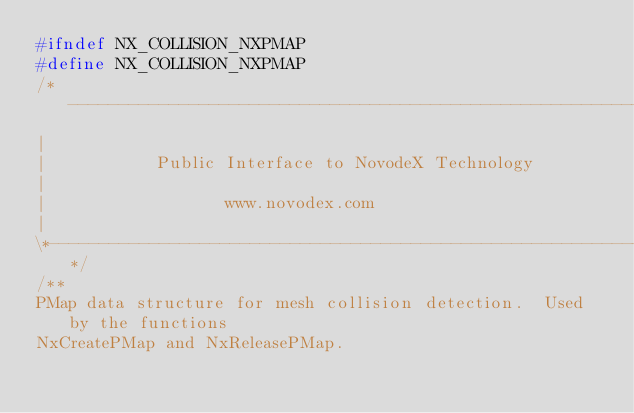Convert code to text. <code><loc_0><loc_0><loc_500><loc_500><_C_>#ifndef NX_COLLISION_NXPMAP
#define NX_COLLISION_NXPMAP
/*----------------------------------------------------------------------------*\
|
|						Public Interface to NovodeX Technology
|
|							     www.novodex.com
|
\*----------------------------------------------------------------------------*/
/**
PMap data structure for mesh collision detection.  Used by the functions
NxCreatePMap and NxReleasePMap.  </code> 